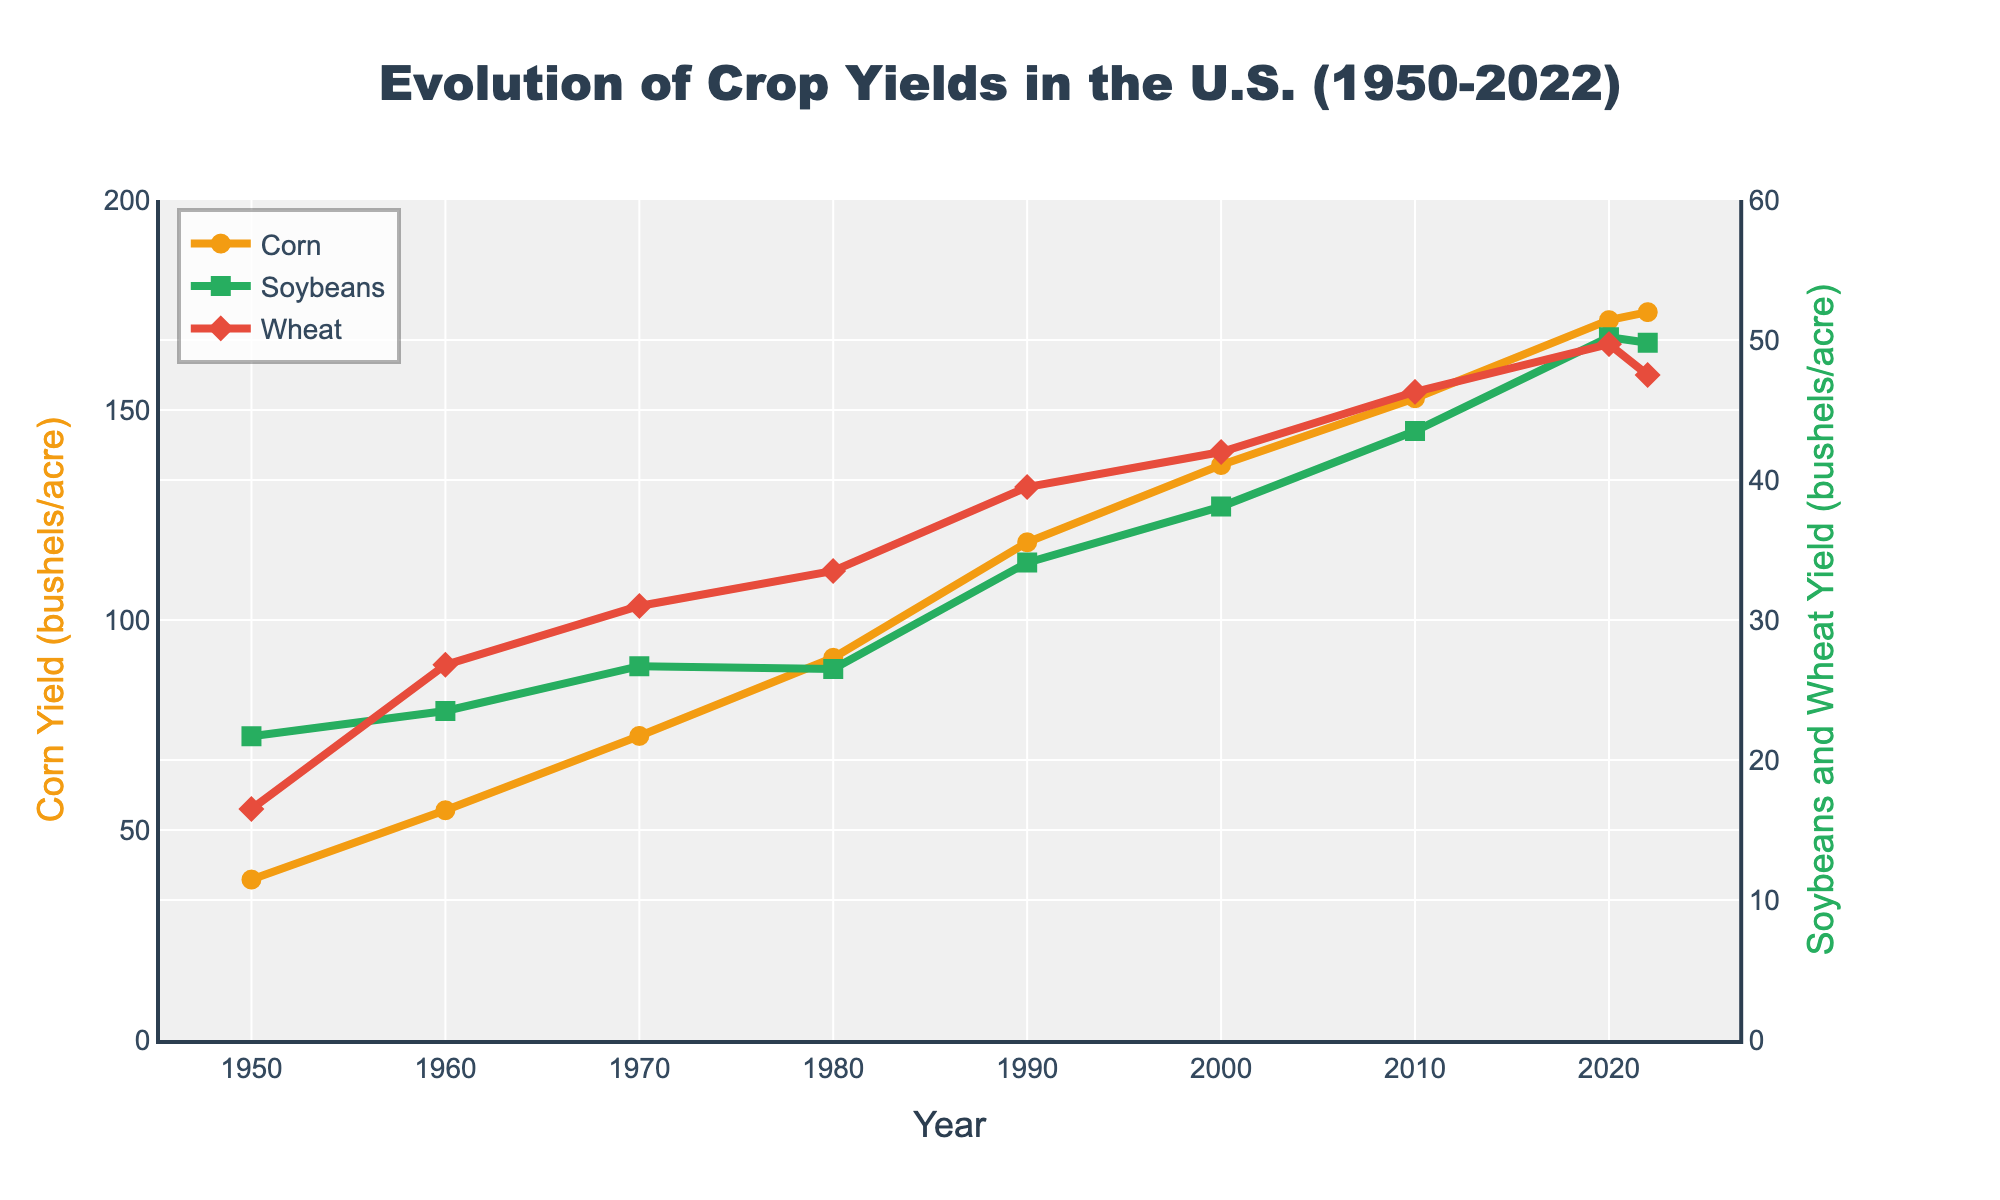What commodity had the highest yield in 2022? By examining the data points in the year 2022, we see that Corn had a yield of 173.3 bushels/acre, Soybeans had 49.8 bushels/acre, and Wheat had 47.5 bushels/acre. Thus, Corn had the highest yield.
Answer: Corn How has the yield of Corn changed from 1950 to 2020? Looking at the plot, the yield of Corn increased from 38.2 bushels/acre in 1950 to 171.4 bushels/acre in 2020. To find the change, subtract 38.2 from 171.4.
Answer: 133.2 bushels/acre Which crop showed the most significant increase in yield between 1950 and 2022? Comparing the initial and final yields: Corn increased from 38.2 to 173.3 (a change of 135.1 bushels/acre), Soybeans from 21.7 to 49.8 (28.1 bushels/acre), and Wheat from 16.5 to 47.5 (31.0 bushels/acre). Corn had the most significant increase.
Answer: Corn What was the average yield of Soybeans in the 21st century (2000 onwards)? The Soybeans yields from 2000 onwards are 38.1 (2000), 43.5 (2010), 50.2 (2020), and 49.8 (2022). The average is calculated as (38.1 + 43.5 + 50.2 + 49.8) / 4.
Answer: 45.4 bushels/acre During which decade did Wheat experience the highest relative increase in yield? Calculating the relative increase for each decade: 1950-1960 (26.8-16.5)/16.5 ≈ 0.63, 1960-1970 (31.0-26.8)/26.8 ≈ 0.16, 1970-1980 (33.5-31.0)/31.0 ≈ 0.08, 1980-1990 (39.5-33.5)/33.5 ≈ 0.18, 1990-2000 (42.0-39.5)/39.5 ≈ 0.06, 2000-2010 (46.3-42.0)/42.0 ≈ 0.10, 2010-2020 (49.7-46.3)/46.3 ≈ 0.07. The highest relative increase occurred in the 1950s.
Answer: 1950s How did the yield of Soybeans compare to Wheat in 1970? In 1970, the plot indicates Soybeans had a yield of 26.7 bushels/acre and Wheat 31.0 bushels/acre. Thus, Wheat had a higher yield than Soybeans in 1970.
Answer: Wheat higher What is the visual difference between the yield lines for Corn and Soybeans from 1980 to 2022? The Corn yield line is higher and increases more steeply over time compared to the Soybeans yield line, which is lower and increases at a slower rate. Corn yield is represented in orange circles, while Soybeans is depicted in green squares. This indicates that Corn consistently yielded more and increased rapidly.
Answer: Corn is higher and steeper Compare the yield growth of Corn between the decades of 1950-1960 and 1990-2000. From 1950-1960, Corn yield increased from 38.2 to 54.7, a change of 16.5 bushels/acre. From 1990-2000, it increased from 118.5 to 136.9, a change of 18.4 bushels/acre. Thus, there was a larger increase in the 1990s.
Answer: 1990s larger What was the trend in Wheat yield between 2010 and 2022? From the plot, Wheat yield increased from 46.3 bushels/acre in 2010 to 49.7 in 2020, but then decreased to 47.5 in 2022. The trend shows an initial increase followed by a small decline.
Answer: Increase then decline 